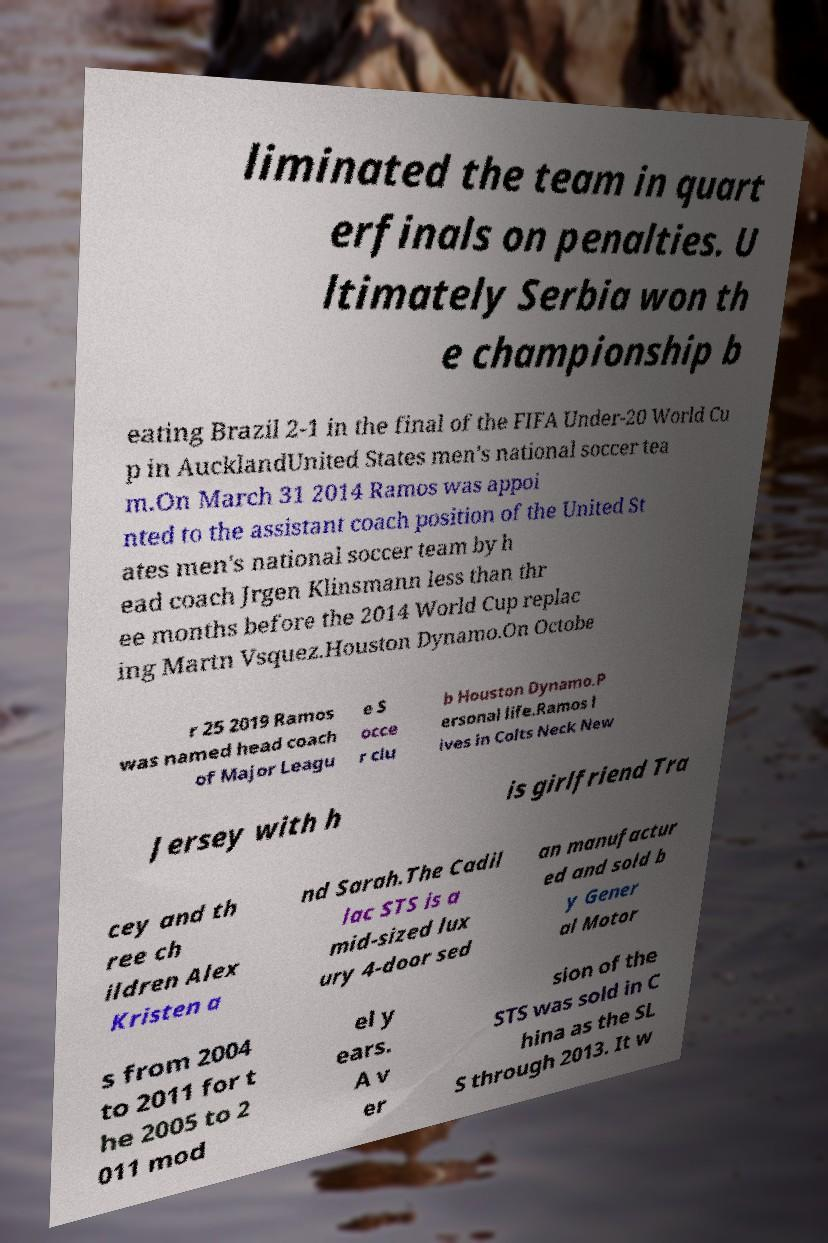Please read and relay the text visible in this image. What does it say? liminated the team in quart erfinals on penalties. U ltimately Serbia won th e championship b eating Brazil 2-1 in the final of the FIFA Under-20 World Cu p in AucklandUnited States men's national soccer tea m.On March 31 2014 Ramos was appoi nted to the assistant coach position of the United St ates men's national soccer team by h ead coach Jrgen Klinsmann less than thr ee months before the 2014 World Cup replac ing Martn Vsquez.Houston Dynamo.On Octobe r 25 2019 Ramos was named head coach of Major Leagu e S occe r clu b Houston Dynamo.P ersonal life.Ramos l ives in Colts Neck New Jersey with h is girlfriend Tra cey and th ree ch ildren Alex Kristen a nd Sarah.The Cadil lac STS is a mid-sized lux ury 4-door sed an manufactur ed and sold b y Gener al Motor s from 2004 to 2011 for t he 2005 to 2 011 mod el y ears. A v er sion of the STS was sold in C hina as the SL S through 2013. It w 